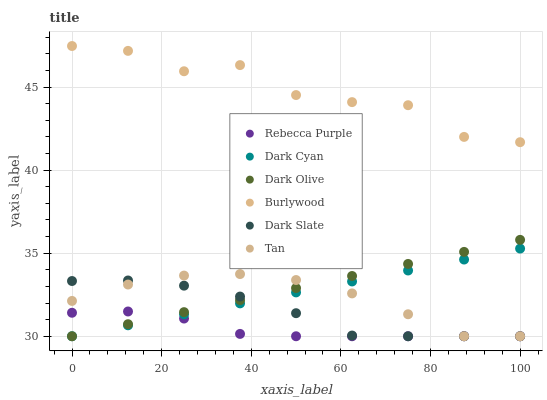Does Rebecca Purple have the minimum area under the curve?
Answer yes or no. Yes. Does Burlywood have the maximum area under the curve?
Answer yes or no. Yes. Does Dark Olive have the minimum area under the curve?
Answer yes or no. No. Does Dark Olive have the maximum area under the curve?
Answer yes or no. No. Is Dark Cyan the smoothest?
Answer yes or no. Yes. Is Burlywood the roughest?
Answer yes or no. Yes. Is Dark Olive the smoothest?
Answer yes or no. No. Is Dark Olive the roughest?
Answer yes or no. No. Does Dark Olive have the lowest value?
Answer yes or no. Yes. Does Burlywood have the highest value?
Answer yes or no. Yes. Does Dark Olive have the highest value?
Answer yes or no. No. Is Dark Olive less than Burlywood?
Answer yes or no. Yes. Is Burlywood greater than Dark Slate?
Answer yes or no. Yes. Does Rebecca Purple intersect Tan?
Answer yes or no. Yes. Is Rebecca Purple less than Tan?
Answer yes or no. No. Is Rebecca Purple greater than Tan?
Answer yes or no. No. Does Dark Olive intersect Burlywood?
Answer yes or no. No. 